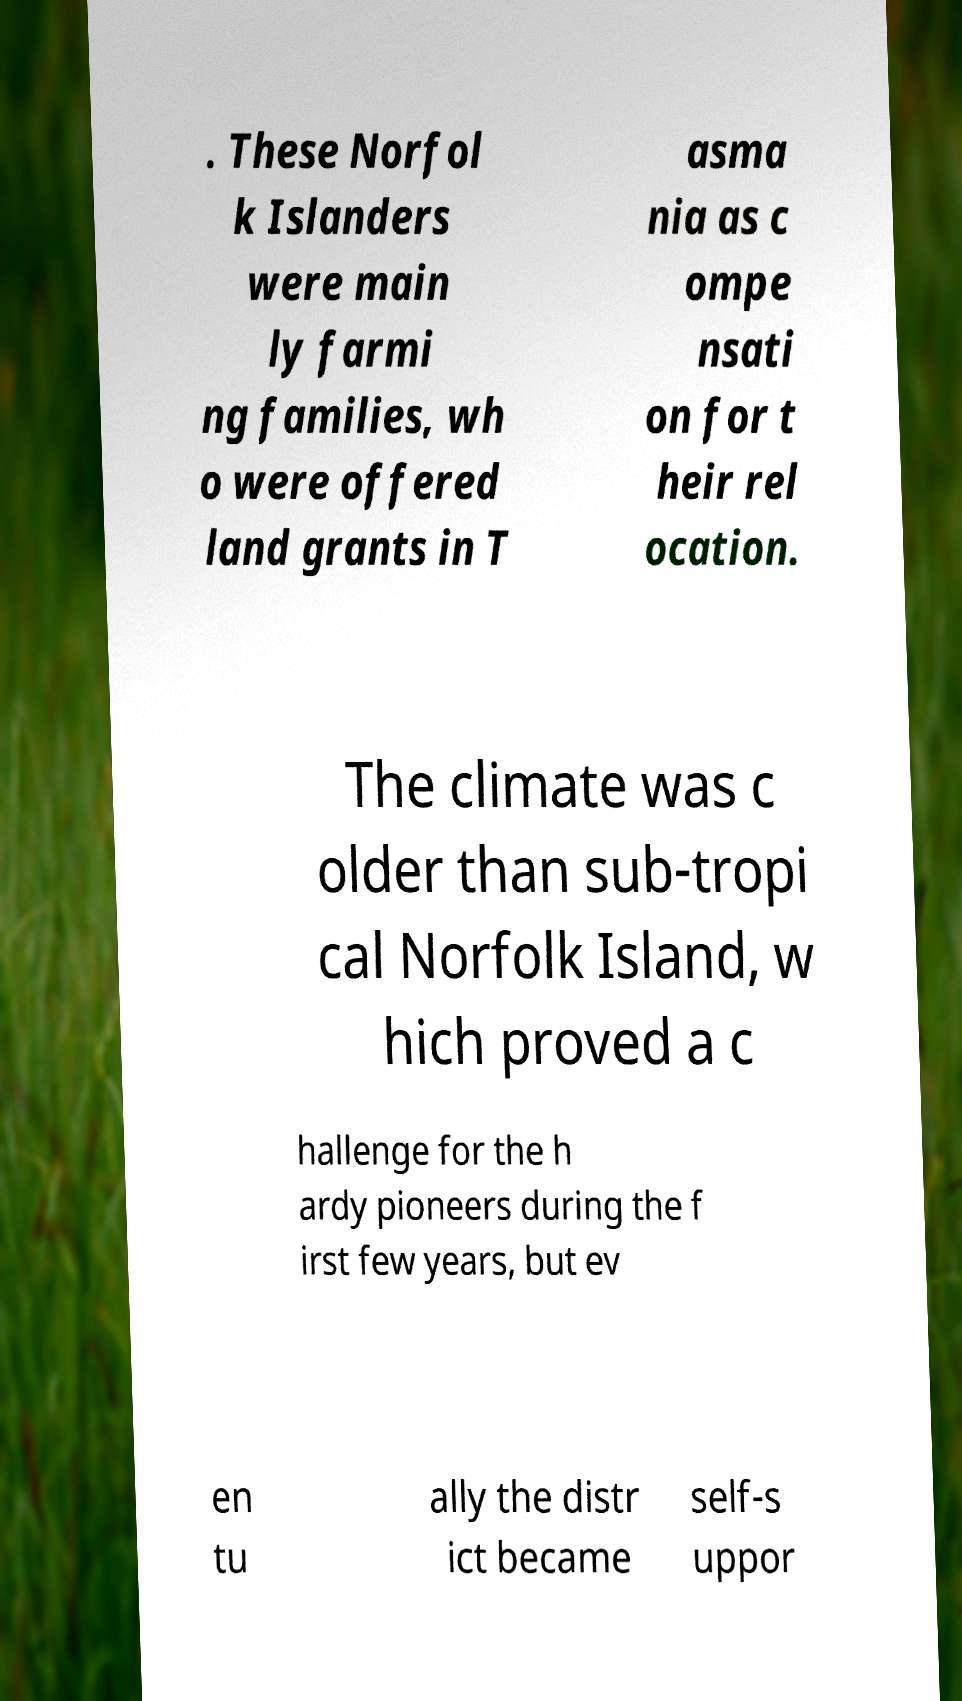What messages or text are displayed in this image? I need them in a readable, typed format. . These Norfol k Islanders were main ly farmi ng families, wh o were offered land grants in T asma nia as c ompe nsati on for t heir rel ocation. The climate was c older than sub-tropi cal Norfolk Island, w hich proved a c hallenge for the h ardy pioneers during the f irst few years, but ev en tu ally the distr ict became self-s uppor 